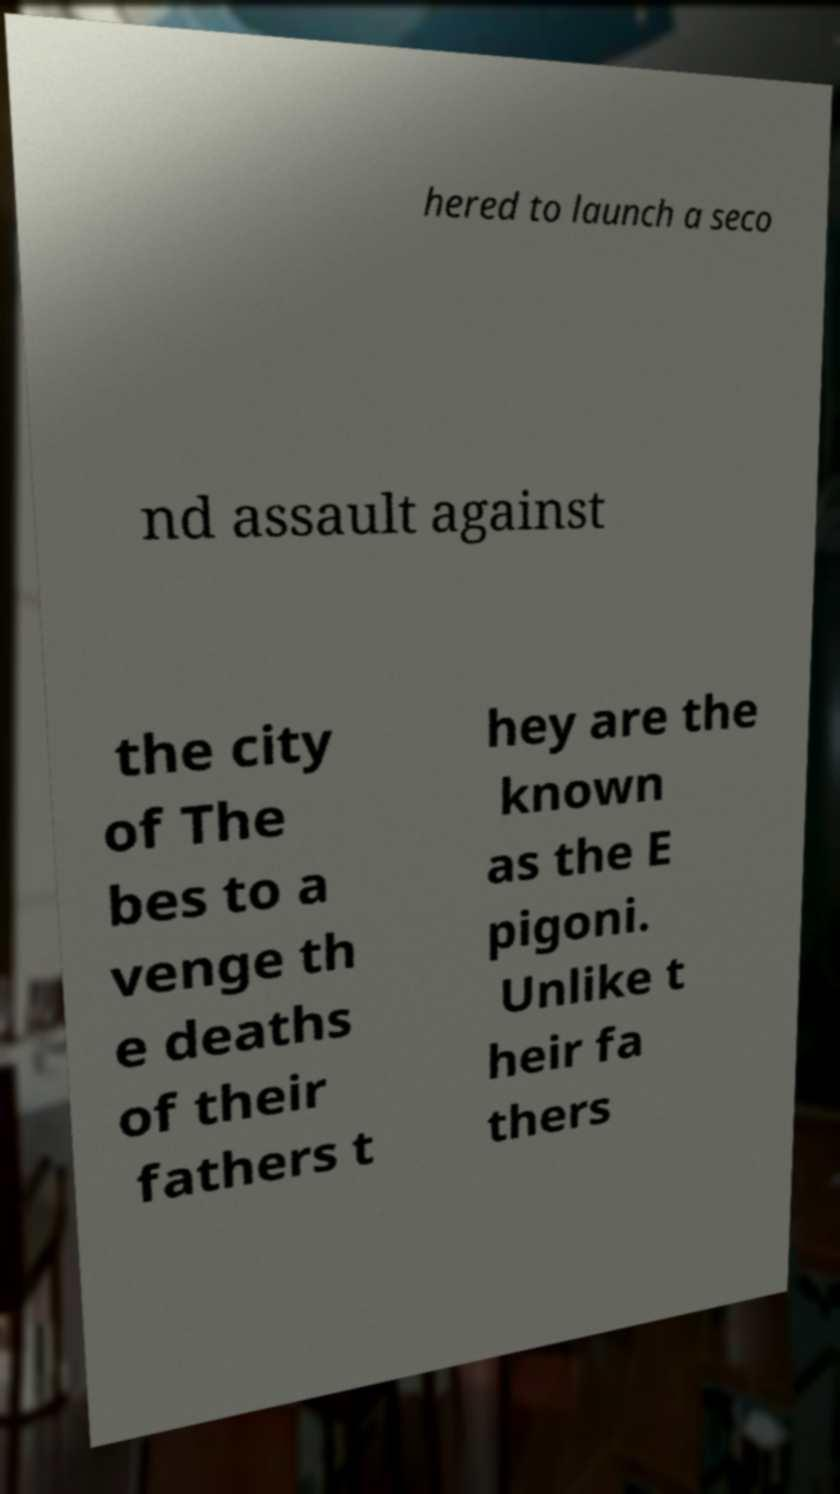What messages or text are displayed in this image? I need them in a readable, typed format. hered to launch a seco nd assault against the city of The bes to a venge th e deaths of their fathers t hey are the known as the E pigoni. Unlike t heir fa thers 